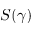<formula> <loc_0><loc_0><loc_500><loc_500>S ( \gamma )</formula> 